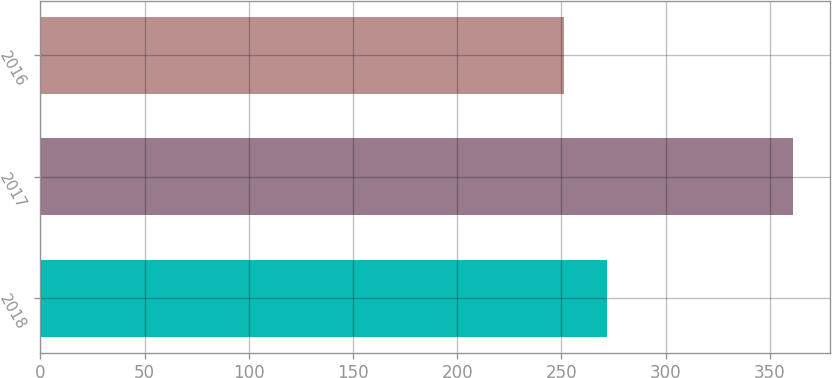<chart> <loc_0><loc_0><loc_500><loc_500><bar_chart><fcel>2018<fcel>2017<fcel>2016<nl><fcel>272<fcel>361<fcel>251<nl></chart> 